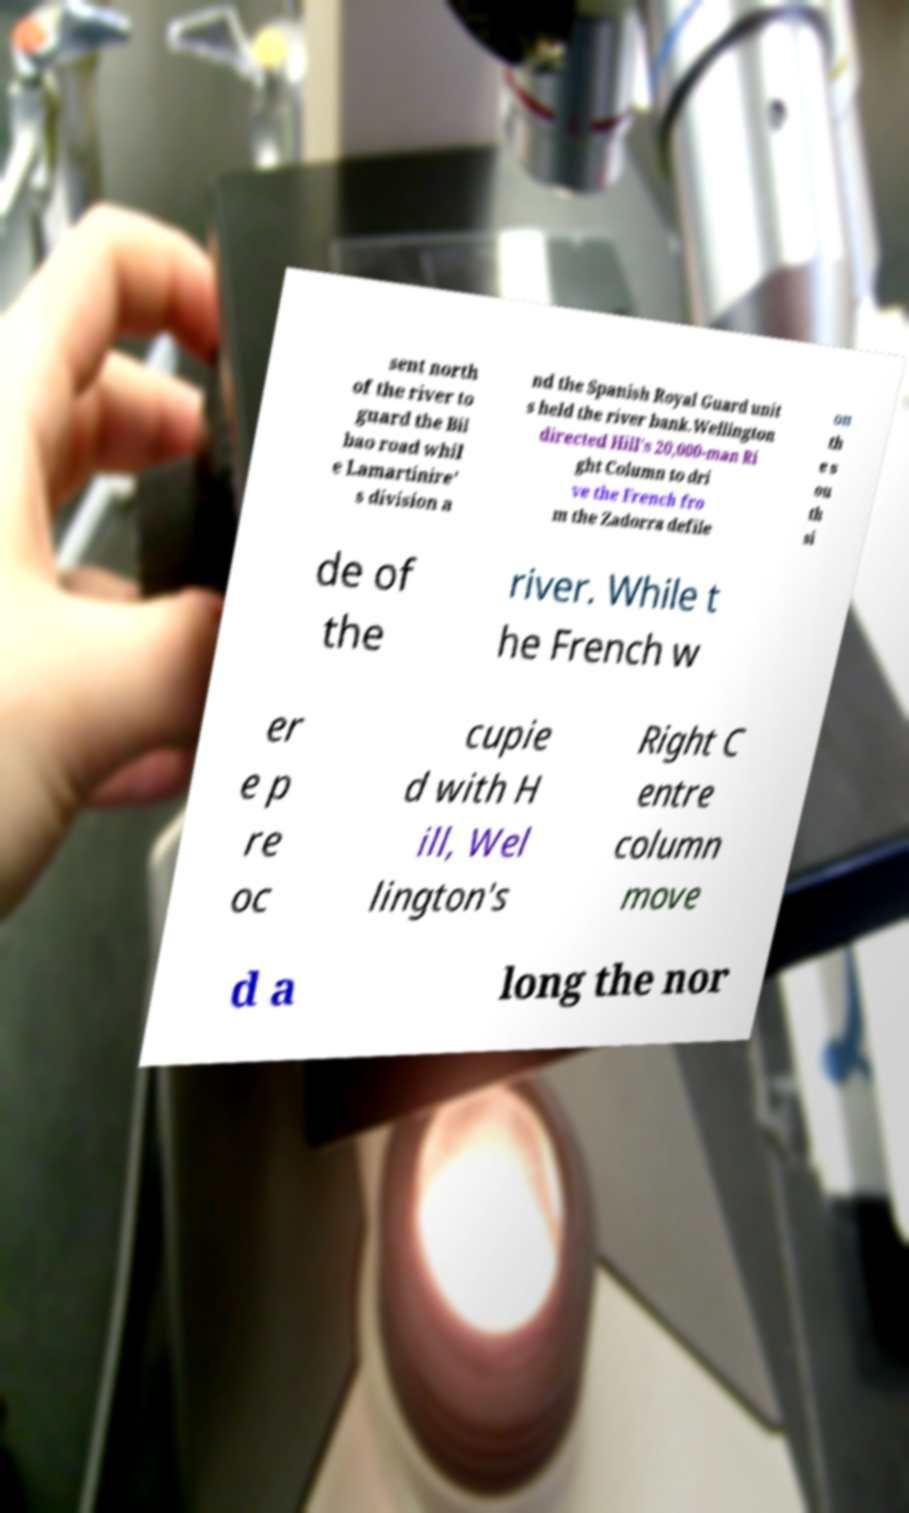For documentation purposes, I need the text within this image transcribed. Could you provide that? sent north of the river to guard the Bil bao road whil e Lamartinire' s division a nd the Spanish Royal Guard unit s held the river bank.Wellington directed Hill's 20,000-man Ri ght Column to dri ve the French fro m the Zadorra defile on th e s ou th si de of the river. While t he French w er e p re oc cupie d with H ill, Wel lington's Right C entre column move d a long the nor 